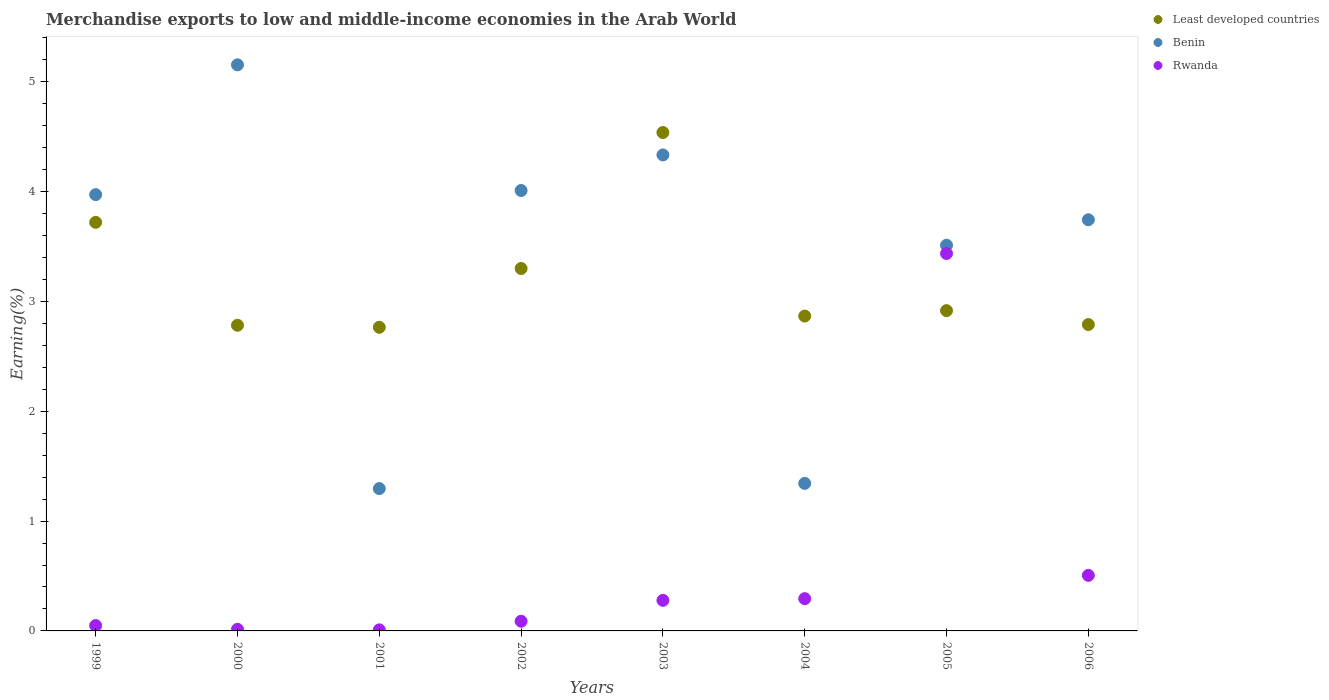What is the percentage of amount earned from merchandise exports in Benin in 1999?
Provide a short and direct response. 3.97. Across all years, what is the maximum percentage of amount earned from merchandise exports in Benin?
Provide a short and direct response. 5.15. Across all years, what is the minimum percentage of amount earned from merchandise exports in Least developed countries?
Keep it short and to the point. 2.76. What is the total percentage of amount earned from merchandise exports in Benin in the graph?
Make the answer very short. 27.37. What is the difference between the percentage of amount earned from merchandise exports in Rwanda in 2005 and that in 2006?
Keep it short and to the point. 2.93. What is the difference between the percentage of amount earned from merchandise exports in Rwanda in 2004 and the percentage of amount earned from merchandise exports in Benin in 2000?
Provide a short and direct response. -4.86. What is the average percentage of amount earned from merchandise exports in Least developed countries per year?
Your response must be concise. 3.21. In the year 2006, what is the difference between the percentage of amount earned from merchandise exports in Benin and percentage of amount earned from merchandise exports in Least developed countries?
Give a very brief answer. 0.95. What is the ratio of the percentage of amount earned from merchandise exports in Rwanda in 2000 to that in 2001?
Your response must be concise. 1.52. Is the percentage of amount earned from merchandise exports in Rwanda in 2004 less than that in 2005?
Make the answer very short. Yes. What is the difference between the highest and the second highest percentage of amount earned from merchandise exports in Benin?
Give a very brief answer. 0.82. What is the difference between the highest and the lowest percentage of amount earned from merchandise exports in Rwanda?
Keep it short and to the point. 3.43. Is the sum of the percentage of amount earned from merchandise exports in Benin in 1999 and 2005 greater than the maximum percentage of amount earned from merchandise exports in Least developed countries across all years?
Ensure brevity in your answer.  Yes. Is it the case that in every year, the sum of the percentage of amount earned from merchandise exports in Least developed countries and percentage of amount earned from merchandise exports in Rwanda  is greater than the percentage of amount earned from merchandise exports in Benin?
Provide a succinct answer. No. Does the percentage of amount earned from merchandise exports in Rwanda monotonically increase over the years?
Keep it short and to the point. No. Is the percentage of amount earned from merchandise exports in Rwanda strictly greater than the percentage of amount earned from merchandise exports in Least developed countries over the years?
Your answer should be compact. No. What is the title of the graph?
Ensure brevity in your answer.  Merchandise exports to low and middle-income economies in the Arab World. What is the label or title of the Y-axis?
Ensure brevity in your answer.  Earning(%). What is the Earning(%) of Least developed countries in 1999?
Offer a very short reply. 3.72. What is the Earning(%) of Benin in 1999?
Provide a short and direct response. 3.97. What is the Earning(%) of Rwanda in 1999?
Give a very brief answer. 0.05. What is the Earning(%) in Least developed countries in 2000?
Make the answer very short. 2.78. What is the Earning(%) in Benin in 2000?
Your answer should be compact. 5.15. What is the Earning(%) of Rwanda in 2000?
Provide a succinct answer. 0.01. What is the Earning(%) in Least developed countries in 2001?
Your response must be concise. 2.76. What is the Earning(%) of Benin in 2001?
Provide a succinct answer. 1.3. What is the Earning(%) of Rwanda in 2001?
Keep it short and to the point. 0.01. What is the Earning(%) in Least developed countries in 2002?
Your response must be concise. 3.3. What is the Earning(%) in Benin in 2002?
Offer a very short reply. 4.01. What is the Earning(%) in Rwanda in 2002?
Your answer should be very brief. 0.09. What is the Earning(%) in Least developed countries in 2003?
Provide a succinct answer. 4.54. What is the Earning(%) in Benin in 2003?
Provide a succinct answer. 4.33. What is the Earning(%) of Rwanda in 2003?
Offer a very short reply. 0.28. What is the Earning(%) of Least developed countries in 2004?
Your answer should be very brief. 2.87. What is the Earning(%) in Benin in 2004?
Give a very brief answer. 1.34. What is the Earning(%) in Rwanda in 2004?
Keep it short and to the point. 0.29. What is the Earning(%) of Least developed countries in 2005?
Your answer should be compact. 2.92. What is the Earning(%) in Benin in 2005?
Your answer should be compact. 3.51. What is the Earning(%) in Rwanda in 2005?
Your response must be concise. 3.44. What is the Earning(%) in Least developed countries in 2006?
Make the answer very short. 2.79. What is the Earning(%) of Benin in 2006?
Provide a succinct answer. 3.74. What is the Earning(%) of Rwanda in 2006?
Your answer should be compact. 0.51. Across all years, what is the maximum Earning(%) of Least developed countries?
Your response must be concise. 4.54. Across all years, what is the maximum Earning(%) in Benin?
Offer a very short reply. 5.15. Across all years, what is the maximum Earning(%) of Rwanda?
Offer a terse response. 3.44. Across all years, what is the minimum Earning(%) of Least developed countries?
Provide a short and direct response. 2.76. Across all years, what is the minimum Earning(%) in Benin?
Ensure brevity in your answer.  1.3. Across all years, what is the minimum Earning(%) of Rwanda?
Offer a terse response. 0.01. What is the total Earning(%) of Least developed countries in the graph?
Offer a terse response. 25.68. What is the total Earning(%) of Benin in the graph?
Provide a succinct answer. 27.37. What is the total Earning(%) of Rwanda in the graph?
Your answer should be very brief. 4.68. What is the difference between the Earning(%) of Least developed countries in 1999 and that in 2000?
Offer a terse response. 0.94. What is the difference between the Earning(%) in Benin in 1999 and that in 2000?
Your answer should be very brief. -1.18. What is the difference between the Earning(%) of Rwanda in 1999 and that in 2000?
Make the answer very short. 0.03. What is the difference between the Earning(%) of Least developed countries in 1999 and that in 2001?
Your answer should be compact. 0.96. What is the difference between the Earning(%) in Benin in 1999 and that in 2001?
Your response must be concise. 2.68. What is the difference between the Earning(%) in Rwanda in 1999 and that in 2001?
Your answer should be compact. 0.04. What is the difference between the Earning(%) of Least developed countries in 1999 and that in 2002?
Your answer should be compact. 0.42. What is the difference between the Earning(%) of Benin in 1999 and that in 2002?
Give a very brief answer. -0.04. What is the difference between the Earning(%) in Rwanda in 1999 and that in 2002?
Make the answer very short. -0.04. What is the difference between the Earning(%) of Least developed countries in 1999 and that in 2003?
Your answer should be compact. -0.82. What is the difference between the Earning(%) of Benin in 1999 and that in 2003?
Keep it short and to the point. -0.36. What is the difference between the Earning(%) of Rwanda in 1999 and that in 2003?
Give a very brief answer. -0.23. What is the difference between the Earning(%) in Least developed countries in 1999 and that in 2004?
Your answer should be very brief. 0.85. What is the difference between the Earning(%) in Benin in 1999 and that in 2004?
Provide a short and direct response. 2.63. What is the difference between the Earning(%) of Rwanda in 1999 and that in 2004?
Offer a very short reply. -0.24. What is the difference between the Earning(%) in Least developed countries in 1999 and that in 2005?
Provide a succinct answer. 0.8. What is the difference between the Earning(%) of Benin in 1999 and that in 2005?
Ensure brevity in your answer.  0.46. What is the difference between the Earning(%) of Rwanda in 1999 and that in 2005?
Ensure brevity in your answer.  -3.39. What is the difference between the Earning(%) of Least developed countries in 1999 and that in 2006?
Your answer should be very brief. 0.93. What is the difference between the Earning(%) of Benin in 1999 and that in 2006?
Your answer should be compact. 0.23. What is the difference between the Earning(%) in Rwanda in 1999 and that in 2006?
Make the answer very short. -0.46. What is the difference between the Earning(%) in Least developed countries in 2000 and that in 2001?
Your answer should be very brief. 0.02. What is the difference between the Earning(%) in Benin in 2000 and that in 2001?
Ensure brevity in your answer.  3.86. What is the difference between the Earning(%) of Rwanda in 2000 and that in 2001?
Offer a terse response. 0.01. What is the difference between the Earning(%) of Least developed countries in 2000 and that in 2002?
Your answer should be compact. -0.52. What is the difference between the Earning(%) of Benin in 2000 and that in 2002?
Make the answer very short. 1.14. What is the difference between the Earning(%) of Rwanda in 2000 and that in 2002?
Offer a very short reply. -0.07. What is the difference between the Earning(%) in Least developed countries in 2000 and that in 2003?
Keep it short and to the point. -1.75. What is the difference between the Earning(%) of Benin in 2000 and that in 2003?
Your answer should be very brief. 0.82. What is the difference between the Earning(%) in Rwanda in 2000 and that in 2003?
Provide a short and direct response. -0.26. What is the difference between the Earning(%) of Least developed countries in 2000 and that in 2004?
Offer a very short reply. -0.08. What is the difference between the Earning(%) in Benin in 2000 and that in 2004?
Ensure brevity in your answer.  3.81. What is the difference between the Earning(%) of Rwanda in 2000 and that in 2004?
Keep it short and to the point. -0.28. What is the difference between the Earning(%) of Least developed countries in 2000 and that in 2005?
Keep it short and to the point. -0.13. What is the difference between the Earning(%) of Benin in 2000 and that in 2005?
Keep it short and to the point. 1.64. What is the difference between the Earning(%) in Rwanda in 2000 and that in 2005?
Your answer should be compact. -3.42. What is the difference between the Earning(%) in Least developed countries in 2000 and that in 2006?
Offer a terse response. -0.01. What is the difference between the Earning(%) of Benin in 2000 and that in 2006?
Offer a terse response. 1.41. What is the difference between the Earning(%) of Rwanda in 2000 and that in 2006?
Ensure brevity in your answer.  -0.49. What is the difference between the Earning(%) of Least developed countries in 2001 and that in 2002?
Provide a short and direct response. -0.54. What is the difference between the Earning(%) of Benin in 2001 and that in 2002?
Provide a short and direct response. -2.71. What is the difference between the Earning(%) of Rwanda in 2001 and that in 2002?
Ensure brevity in your answer.  -0.08. What is the difference between the Earning(%) of Least developed countries in 2001 and that in 2003?
Ensure brevity in your answer.  -1.77. What is the difference between the Earning(%) of Benin in 2001 and that in 2003?
Your answer should be compact. -3.04. What is the difference between the Earning(%) of Rwanda in 2001 and that in 2003?
Your response must be concise. -0.27. What is the difference between the Earning(%) in Least developed countries in 2001 and that in 2004?
Give a very brief answer. -0.1. What is the difference between the Earning(%) of Benin in 2001 and that in 2004?
Keep it short and to the point. -0.05. What is the difference between the Earning(%) in Rwanda in 2001 and that in 2004?
Provide a succinct answer. -0.28. What is the difference between the Earning(%) in Least developed countries in 2001 and that in 2005?
Give a very brief answer. -0.15. What is the difference between the Earning(%) of Benin in 2001 and that in 2005?
Make the answer very short. -2.22. What is the difference between the Earning(%) of Rwanda in 2001 and that in 2005?
Provide a short and direct response. -3.43. What is the difference between the Earning(%) of Least developed countries in 2001 and that in 2006?
Offer a terse response. -0.02. What is the difference between the Earning(%) in Benin in 2001 and that in 2006?
Offer a very short reply. -2.45. What is the difference between the Earning(%) of Rwanda in 2001 and that in 2006?
Give a very brief answer. -0.5. What is the difference between the Earning(%) in Least developed countries in 2002 and that in 2003?
Provide a succinct answer. -1.24. What is the difference between the Earning(%) in Benin in 2002 and that in 2003?
Your response must be concise. -0.32. What is the difference between the Earning(%) in Rwanda in 2002 and that in 2003?
Provide a short and direct response. -0.19. What is the difference between the Earning(%) in Least developed countries in 2002 and that in 2004?
Provide a short and direct response. 0.43. What is the difference between the Earning(%) in Benin in 2002 and that in 2004?
Make the answer very short. 2.67. What is the difference between the Earning(%) in Rwanda in 2002 and that in 2004?
Offer a terse response. -0.21. What is the difference between the Earning(%) of Least developed countries in 2002 and that in 2005?
Provide a short and direct response. 0.38. What is the difference between the Earning(%) in Benin in 2002 and that in 2005?
Keep it short and to the point. 0.5. What is the difference between the Earning(%) in Rwanda in 2002 and that in 2005?
Make the answer very short. -3.35. What is the difference between the Earning(%) of Least developed countries in 2002 and that in 2006?
Ensure brevity in your answer.  0.51. What is the difference between the Earning(%) in Benin in 2002 and that in 2006?
Make the answer very short. 0.27. What is the difference between the Earning(%) in Rwanda in 2002 and that in 2006?
Your answer should be very brief. -0.42. What is the difference between the Earning(%) of Least developed countries in 2003 and that in 2004?
Provide a short and direct response. 1.67. What is the difference between the Earning(%) in Benin in 2003 and that in 2004?
Provide a short and direct response. 2.99. What is the difference between the Earning(%) of Rwanda in 2003 and that in 2004?
Provide a short and direct response. -0.02. What is the difference between the Earning(%) of Least developed countries in 2003 and that in 2005?
Make the answer very short. 1.62. What is the difference between the Earning(%) of Benin in 2003 and that in 2005?
Give a very brief answer. 0.82. What is the difference between the Earning(%) of Rwanda in 2003 and that in 2005?
Provide a succinct answer. -3.16. What is the difference between the Earning(%) of Least developed countries in 2003 and that in 2006?
Make the answer very short. 1.75. What is the difference between the Earning(%) of Benin in 2003 and that in 2006?
Your answer should be compact. 0.59. What is the difference between the Earning(%) of Rwanda in 2003 and that in 2006?
Make the answer very short. -0.23. What is the difference between the Earning(%) of Least developed countries in 2004 and that in 2005?
Offer a very short reply. -0.05. What is the difference between the Earning(%) of Benin in 2004 and that in 2005?
Give a very brief answer. -2.17. What is the difference between the Earning(%) of Rwanda in 2004 and that in 2005?
Offer a terse response. -3.14. What is the difference between the Earning(%) in Least developed countries in 2004 and that in 2006?
Make the answer very short. 0.08. What is the difference between the Earning(%) in Benin in 2004 and that in 2006?
Offer a terse response. -2.4. What is the difference between the Earning(%) of Rwanda in 2004 and that in 2006?
Your answer should be compact. -0.21. What is the difference between the Earning(%) of Least developed countries in 2005 and that in 2006?
Your response must be concise. 0.13. What is the difference between the Earning(%) in Benin in 2005 and that in 2006?
Make the answer very short. -0.23. What is the difference between the Earning(%) in Rwanda in 2005 and that in 2006?
Give a very brief answer. 2.93. What is the difference between the Earning(%) in Least developed countries in 1999 and the Earning(%) in Benin in 2000?
Give a very brief answer. -1.43. What is the difference between the Earning(%) of Least developed countries in 1999 and the Earning(%) of Rwanda in 2000?
Ensure brevity in your answer.  3.71. What is the difference between the Earning(%) of Benin in 1999 and the Earning(%) of Rwanda in 2000?
Make the answer very short. 3.96. What is the difference between the Earning(%) of Least developed countries in 1999 and the Earning(%) of Benin in 2001?
Ensure brevity in your answer.  2.42. What is the difference between the Earning(%) of Least developed countries in 1999 and the Earning(%) of Rwanda in 2001?
Give a very brief answer. 3.71. What is the difference between the Earning(%) of Benin in 1999 and the Earning(%) of Rwanda in 2001?
Your answer should be compact. 3.96. What is the difference between the Earning(%) in Least developed countries in 1999 and the Earning(%) in Benin in 2002?
Provide a succinct answer. -0.29. What is the difference between the Earning(%) of Least developed countries in 1999 and the Earning(%) of Rwanda in 2002?
Keep it short and to the point. 3.63. What is the difference between the Earning(%) of Benin in 1999 and the Earning(%) of Rwanda in 2002?
Your answer should be very brief. 3.88. What is the difference between the Earning(%) of Least developed countries in 1999 and the Earning(%) of Benin in 2003?
Your response must be concise. -0.61. What is the difference between the Earning(%) in Least developed countries in 1999 and the Earning(%) in Rwanda in 2003?
Your answer should be very brief. 3.44. What is the difference between the Earning(%) of Benin in 1999 and the Earning(%) of Rwanda in 2003?
Offer a terse response. 3.69. What is the difference between the Earning(%) in Least developed countries in 1999 and the Earning(%) in Benin in 2004?
Offer a very short reply. 2.38. What is the difference between the Earning(%) of Least developed countries in 1999 and the Earning(%) of Rwanda in 2004?
Your answer should be compact. 3.43. What is the difference between the Earning(%) in Benin in 1999 and the Earning(%) in Rwanda in 2004?
Provide a short and direct response. 3.68. What is the difference between the Earning(%) of Least developed countries in 1999 and the Earning(%) of Benin in 2005?
Ensure brevity in your answer.  0.21. What is the difference between the Earning(%) in Least developed countries in 1999 and the Earning(%) in Rwanda in 2005?
Make the answer very short. 0.28. What is the difference between the Earning(%) of Benin in 1999 and the Earning(%) of Rwanda in 2005?
Provide a short and direct response. 0.54. What is the difference between the Earning(%) of Least developed countries in 1999 and the Earning(%) of Benin in 2006?
Give a very brief answer. -0.02. What is the difference between the Earning(%) of Least developed countries in 1999 and the Earning(%) of Rwanda in 2006?
Offer a very short reply. 3.21. What is the difference between the Earning(%) in Benin in 1999 and the Earning(%) in Rwanda in 2006?
Your answer should be compact. 3.47. What is the difference between the Earning(%) of Least developed countries in 2000 and the Earning(%) of Benin in 2001?
Your answer should be compact. 1.49. What is the difference between the Earning(%) of Least developed countries in 2000 and the Earning(%) of Rwanda in 2001?
Ensure brevity in your answer.  2.77. What is the difference between the Earning(%) of Benin in 2000 and the Earning(%) of Rwanda in 2001?
Your answer should be very brief. 5.14. What is the difference between the Earning(%) of Least developed countries in 2000 and the Earning(%) of Benin in 2002?
Offer a very short reply. -1.23. What is the difference between the Earning(%) in Least developed countries in 2000 and the Earning(%) in Rwanda in 2002?
Make the answer very short. 2.69. What is the difference between the Earning(%) of Benin in 2000 and the Earning(%) of Rwanda in 2002?
Your answer should be very brief. 5.07. What is the difference between the Earning(%) in Least developed countries in 2000 and the Earning(%) in Benin in 2003?
Your answer should be compact. -1.55. What is the difference between the Earning(%) in Least developed countries in 2000 and the Earning(%) in Rwanda in 2003?
Your answer should be very brief. 2.5. What is the difference between the Earning(%) of Benin in 2000 and the Earning(%) of Rwanda in 2003?
Ensure brevity in your answer.  4.88. What is the difference between the Earning(%) of Least developed countries in 2000 and the Earning(%) of Benin in 2004?
Offer a very short reply. 1.44. What is the difference between the Earning(%) of Least developed countries in 2000 and the Earning(%) of Rwanda in 2004?
Offer a very short reply. 2.49. What is the difference between the Earning(%) of Benin in 2000 and the Earning(%) of Rwanda in 2004?
Keep it short and to the point. 4.86. What is the difference between the Earning(%) of Least developed countries in 2000 and the Earning(%) of Benin in 2005?
Provide a short and direct response. -0.73. What is the difference between the Earning(%) in Least developed countries in 2000 and the Earning(%) in Rwanda in 2005?
Provide a succinct answer. -0.65. What is the difference between the Earning(%) in Benin in 2000 and the Earning(%) in Rwanda in 2005?
Make the answer very short. 1.72. What is the difference between the Earning(%) of Least developed countries in 2000 and the Earning(%) of Benin in 2006?
Your answer should be very brief. -0.96. What is the difference between the Earning(%) of Least developed countries in 2000 and the Earning(%) of Rwanda in 2006?
Keep it short and to the point. 2.28. What is the difference between the Earning(%) of Benin in 2000 and the Earning(%) of Rwanda in 2006?
Your answer should be very brief. 4.65. What is the difference between the Earning(%) of Least developed countries in 2001 and the Earning(%) of Benin in 2002?
Keep it short and to the point. -1.25. What is the difference between the Earning(%) of Least developed countries in 2001 and the Earning(%) of Rwanda in 2002?
Offer a very short reply. 2.68. What is the difference between the Earning(%) of Benin in 2001 and the Earning(%) of Rwanda in 2002?
Provide a succinct answer. 1.21. What is the difference between the Earning(%) in Least developed countries in 2001 and the Earning(%) in Benin in 2003?
Ensure brevity in your answer.  -1.57. What is the difference between the Earning(%) in Least developed countries in 2001 and the Earning(%) in Rwanda in 2003?
Your answer should be compact. 2.49. What is the difference between the Earning(%) of Benin in 2001 and the Earning(%) of Rwanda in 2003?
Make the answer very short. 1.02. What is the difference between the Earning(%) in Least developed countries in 2001 and the Earning(%) in Benin in 2004?
Keep it short and to the point. 1.42. What is the difference between the Earning(%) of Least developed countries in 2001 and the Earning(%) of Rwanda in 2004?
Keep it short and to the point. 2.47. What is the difference between the Earning(%) of Benin in 2001 and the Earning(%) of Rwanda in 2004?
Your response must be concise. 1. What is the difference between the Earning(%) of Least developed countries in 2001 and the Earning(%) of Benin in 2005?
Offer a terse response. -0.75. What is the difference between the Earning(%) in Least developed countries in 2001 and the Earning(%) in Rwanda in 2005?
Keep it short and to the point. -0.67. What is the difference between the Earning(%) in Benin in 2001 and the Earning(%) in Rwanda in 2005?
Ensure brevity in your answer.  -2.14. What is the difference between the Earning(%) in Least developed countries in 2001 and the Earning(%) in Benin in 2006?
Ensure brevity in your answer.  -0.98. What is the difference between the Earning(%) in Least developed countries in 2001 and the Earning(%) in Rwanda in 2006?
Make the answer very short. 2.26. What is the difference between the Earning(%) of Benin in 2001 and the Earning(%) of Rwanda in 2006?
Keep it short and to the point. 0.79. What is the difference between the Earning(%) of Least developed countries in 2002 and the Earning(%) of Benin in 2003?
Your answer should be very brief. -1.03. What is the difference between the Earning(%) of Least developed countries in 2002 and the Earning(%) of Rwanda in 2003?
Give a very brief answer. 3.02. What is the difference between the Earning(%) of Benin in 2002 and the Earning(%) of Rwanda in 2003?
Make the answer very short. 3.73. What is the difference between the Earning(%) in Least developed countries in 2002 and the Earning(%) in Benin in 2004?
Provide a short and direct response. 1.96. What is the difference between the Earning(%) in Least developed countries in 2002 and the Earning(%) in Rwanda in 2004?
Keep it short and to the point. 3.01. What is the difference between the Earning(%) of Benin in 2002 and the Earning(%) of Rwanda in 2004?
Give a very brief answer. 3.72. What is the difference between the Earning(%) in Least developed countries in 2002 and the Earning(%) in Benin in 2005?
Ensure brevity in your answer.  -0.21. What is the difference between the Earning(%) of Least developed countries in 2002 and the Earning(%) of Rwanda in 2005?
Ensure brevity in your answer.  -0.14. What is the difference between the Earning(%) of Benin in 2002 and the Earning(%) of Rwanda in 2005?
Ensure brevity in your answer.  0.57. What is the difference between the Earning(%) of Least developed countries in 2002 and the Earning(%) of Benin in 2006?
Provide a short and direct response. -0.44. What is the difference between the Earning(%) of Least developed countries in 2002 and the Earning(%) of Rwanda in 2006?
Keep it short and to the point. 2.79. What is the difference between the Earning(%) of Benin in 2002 and the Earning(%) of Rwanda in 2006?
Your answer should be compact. 3.5. What is the difference between the Earning(%) in Least developed countries in 2003 and the Earning(%) in Benin in 2004?
Provide a succinct answer. 3.19. What is the difference between the Earning(%) of Least developed countries in 2003 and the Earning(%) of Rwanda in 2004?
Your response must be concise. 4.24. What is the difference between the Earning(%) of Benin in 2003 and the Earning(%) of Rwanda in 2004?
Make the answer very short. 4.04. What is the difference between the Earning(%) of Least developed countries in 2003 and the Earning(%) of Benin in 2005?
Keep it short and to the point. 1.03. What is the difference between the Earning(%) of Least developed countries in 2003 and the Earning(%) of Rwanda in 2005?
Keep it short and to the point. 1.1. What is the difference between the Earning(%) in Benin in 2003 and the Earning(%) in Rwanda in 2005?
Provide a short and direct response. 0.9. What is the difference between the Earning(%) in Least developed countries in 2003 and the Earning(%) in Benin in 2006?
Ensure brevity in your answer.  0.79. What is the difference between the Earning(%) in Least developed countries in 2003 and the Earning(%) in Rwanda in 2006?
Provide a short and direct response. 4.03. What is the difference between the Earning(%) of Benin in 2003 and the Earning(%) of Rwanda in 2006?
Give a very brief answer. 3.83. What is the difference between the Earning(%) of Least developed countries in 2004 and the Earning(%) of Benin in 2005?
Your answer should be very brief. -0.64. What is the difference between the Earning(%) of Least developed countries in 2004 and the Earning(%) of Rwanda in 2005?
Make the answer very short. -0.57. What is the difference between the Earning(%) in Benin in 2004 and the Earning(%) in Rwanda in 2005?
Ensure brevity in your answer.  -2.09. What is the difference between the Earning(%) of Least developed countries in 2004 and the Earning(%) of Benin in 2006?
Keep it short and to the point. -0.88. What is the difference between the Earning(%) in Least developed countries in 2004 and the Earning(%) in Rwanda in 2006?
Give a very brief answer. 2.36. What is the difference between the Earning(%) of Benin in 2004 and the Earning(%) of Rwanda in 2006?
Offer a very short reply. 0.84. What is the difference between the Earning(%) of Least developed countries in 2005 and the Earning(%) of Benin in 2006?
Your answer should be very brief. -0.83. What is the difference between the Earning(%) of Least developed countries in 2005 and the Earning(%) of Rwanda in 2006?
Your response must be concise. 2.41. What is the difference between the Earning(%) in Benin in 2005 and the Earning(%) in Rwanda in 2006?
Your answer should be compact. 3.01. What is the average Earning(%) of Least developed countries per year?
Ensure brevity in your answer.  3.21. What is the average Earning(%) of Benin per year?
Give a very brief answer. 3.42. What is the average Earning(%) of Rwanda per year?
Your response must be concise. 0.58. In the year 1999, what is the difference between the Earning(%) of Least developed countries and Earning(%) of Benin?
Provide a short and direct response. -0.25. In the year 1999, what is the difference between the Earning(%) of Least developed countries and Earning(%) of Rwanda?
Provide a short and direct response. 3.67. In the year 1999, what is the difference between the Earning(%) of Benin and Earning(%) of Rwanda?
Your answer should be compact. 3.92. In the year 2000, what is the difference between the Earning(%) of Least developed countries and Earning(%) of Benin?
Offer a very short reply. -2.37. In the year 2000, what is the difference between the Earning(%) in Least developed countries and Earning(%) in Rwanda?
Offer a terse response. 2.77. In the year 2000, what is the difference between the Earning(%) in Benin and Earning(%) in Rwanda?
Offer a terse response. 5.14. In the year 2001, what is the difference between the Earning(%) in Least developed countries and Earning(%) in Benin?
Your answer should be very brief. 1.47. In the year 2001, what is the difference between the Earning(%) in Least developed countries and Earning(%) in Rwanda?
Keep it short and to the point. 2.75. In the year 2001, what is the difference between the Earning(%) of Benin and Earning(%) of Rwanda?
Keep it short and to the point. 1.29. In the year 2002, what is the difference between the Earning(%) of Least developed countries and Earning(%) of Benin?
Give a very brief answer. -0.71. In the year 2002, what is the difference between the Earning(%) of Least developed countries and Earning(%) of Rwanda?
Make the answer very short. 3.21. In the year 2002, what is the difference between the Earning(%) of Benin and Earning(%) of Rwanda?
Offer a terse response. 3.92. In the year 2003, what is the difference between the Earning(%) in Least developed countries and Earning(%) in Benin?
Provide a short and direct response. 0.2. In the year 2003, what is the difference between the Earning(%) in Least developed countries and Earning(%) in Rwanda?
Your answer should be very brief. 4.26. In the year 2003, what is the difference between the Earning(%) in Benin and Earning(%) in Rwanda?
Offer a very short reply. 4.06. In the year 2004, what is the difference between the Earning(%) of Least developed countries and Earning(%) of Benin?
Provide a succinct answer. 1.52. In the year 2004, what is the difference between the Earning(%) of Least developed countries and Earning(%) of Rwanda?
Give a very brief answer. 2.57. In the year 2004, what is the difference between the Earning(%) of Benin and Earning(%) of Rwanda?
Make the answer very short. 1.05. In the year 2005, what is the difference between the Earning(%) in Least developed countries and Earning(%) in Benin?
Your answer should be compact. -0.6. In the year 2005, what is the difference between the Earning(%) in Least developed countries and Earning(%) in Rwanda?
Offer a terse response. -0.52. In the year 2005, what is the difference between the Earning(%) in Benin and Earning(%) in Rwanda?
Make the answer very short. 0.08. In the year 2006, what is the difference between the Earning(%) of Least developed countries and Earning(%) of Benin?
Offer a very short reply. -0.95. In the year 2006, what is the difference between the Earning(%) in Least developed countries and Earning(%) in Rwanda?
Ensure brevity in your answer.  2.28. In the year 2006, what is the difference between the Earning(%) of Benin and Earning(%) of Rwanda?
Your answer should be compact. 3.24. What is the ratio of the Earning(%) in Least developed countries in 1999 to that in 2000?
Offer a very short reply. 1.34. What is the ratio of the Earning(%) of Benin in 1999 to that in 2000?
Offer a very short reply. 0.77. What is the ratio of the Earning(%) in Rwanda in 1999 to that in 2000?
Your answer should be compact. 3.3. What is the ratio of the Earning(%) of Least developed countries in 1999 to that in 2001?
Give a very brief answer. 1.35. What is the ratio of the Earning(%) of Benin in 1999 to that in 2001?
Make the answer very short. 3.07. What is the ratio of the Earning(%) of Rwanda in 1999 to that in 2001?
Ensure brevity in your answer.  5.01. What is the ratio of the Earning(%) in Least developed countries in 1999 to that in 2002?
Offer a very short reply. 1.13. What is the ratio of the Earning(%) in Benin in 1999 to that in 2002?
Provide a short and direct response. 0.99. What is the ratio of the Earning(%) in Rwanda in 1999 to that in 2002?
Keep it short and to the point. 0.55. What is the ratio of the Earning(%) of Least developed countries in 1999 to that in 2003?
Your response must be concise. 0.82. What is the ratio of the Earning(%) in Benin in 1999 to that in 2003?
Make the answer very short. 0.92. What is the ratio of the Earning(%) of Rwanda in 1999 to that in 2003?
Your answer should be very brief. 0.18. What is the ratio of the Earning(%) in Least developed countries in 1999 to that in 2004?
Provide a short and direct response. 1.3. What is the ratio of the Earning(%) of Benin in 1999 to that in 2004?
Your answer should be very brief. 2.96. What is the ratio of the Earning(%) of Rwanda in 1999 to that in 2004?
Your answer should be compact. 0.17. What is the ratio of the Earning(%) in Least developed countries in 1999 to that in 2005?
Give a very brief answer. 1.28. What is the ratio of the Earning(%) in Benin in 1999 to that in 2005?
Your response must be concise. 1.13. What is the ratio of the Earning(%) in Rwanda in 1999 to that in 2005?
Keep it short and to the point. 0.01. What is the ratio of the Earning(%) in Least developed countries in 1999 to that in 2006?
Provide a succinct answer. 1.33. What is the ratio of the Earning(%) in Benin in 1999 to that in 2006?
Provide a succinct answer. 1.06. What is the ratio of the Earning(%) in Rwanda in 1999 to that in 2006?
Your answer should be compact. 0.1. What is the ratio of the Earning(%) in Least developed countries in 2000 to that in 2001?
Offer a terse response. 1.01. What is the ratio of the Earning(%) of Benin in 2000 to that in 2001?
Your answer should be compact. 3.98. What is the ratio of the Earning(%) in Rwanda in 2000 to that in 2001?
Make the answer very short. 1.52. What is the ratio of the Earning(%) in Least developed countries in 2000 to that in 2002?
Offer a terse response. 0.84. What is the ratio of the Earning(%) in Benin in 2000 to that in 2002?
Ensure brevity in your answer.  1.29. What is the ratio of the Earning(%) in Rwanda in 2000 to that in 2002?
Ensure brevity in your answer.  0.17. What is the ratio of the Earning(%) in Least developed countries in 2000 to that in 2003?
Your answer should be compact. 0.61. What is the ratio of the Earning(%) of Benin in 2000 to that in 2003?
Provide a succinct answer. 1.19. What is the ratio of the Earning(%) of Rwanda in 2000 to that in 2003?
Keep it short and to the point. 0.05. What is the ratio of the Earning(%) in Least developed countries in 2000 to that in 2004?
Provide a succinct answer. 0.97. What is the ratio of the Earning(%) of Benin in 2000 to that in 2004?
Your answer should be very brief. 3.84. What is the ratio of the Earning(%) of Rwanda in 2000 to that in 2004?
Ensure brevity in your answer.  0.05. What is the ratio of the Earning(%) in Least developed countries in 2000 to that in 2005?
Ensure brevity in your answer.  0.95. What is the ratio of the Earning(%) in Benin in 2000 to that in 2005?
Your answer should be compact. 1.47. What is the ratio of the Earning(%) in Rwanda in 2000 to that in 2005?
Ensure brevity in your answer.  0. What is the ratio of the Earning(%) of Least developed countries in 2000 to that in 2006?
Your response must be concise. 1. What is the ratio of the Earning(%) of Benin in 2000 to that in 2006?
Offer a terse response. 1.38. What is the ratio of the Earning(%) of Rwanda in 2000 to that in 2006?
Provide a succinct answer. 0.03. What is the ratio of the Earning(%) of Least developed countries in 2001 to that in 2002?
Offer a very short reply. 0.84. What is the ratio of the Earning(%) of Benin in 2001 to that in 2002?
Provide a succinct answer. 0.32. What is the ratio of the Earning(%) of Rwanda in 2001 to that in 2002?
Provide a short and direct response. 0.11. What is the ratio of the Earning(%) in Least developed countries in 2001 to that in 2003?
Offer a very short reply. 0.61. What is the ratio of the Earning(%) in Benin in 2001 to that in 2003?
Your response must be concise. 0.3. What is the ratio of the Earning(%) of Rwanda in 2001 to that in 2003?
Your answer should be compact. 0.04. What is the ratio of the Earning(%) in Least developed countries in 2001 to that in 2004?
Provide a short and direct response. 0.96. What is the ratio of the Earning(%) of Benin in 2001 to that in 2004?
Offer a terse response. 0.96. What is the ratio of the Earning(%) of Rwanda in 2001 to that in 2004?
Keep it short and to the point. 0.03. What is the ratio of the Earning(%) in Least developed countries in 2001 to that in 2005?
Offer a very short reply. 0.95. What is the ratio of the Earning(%) of Benin in 2001 to that in 2005?
Your response must be concise. 0.37. What is the ratio of the Earning(%) in Rwanda in 2001 to that in 2005?
Make the answer very short. 0. What is the ratio of the Earning(%) in Benin in 2001 to that in 2006?
Your answer should be compact. 0.35. What is the ratio of the Earning(%) in Rwanda in 2001 to that in 2006?
Give a very brief answer. 0.02. What is the ratio of the Earning(%) of Least developed countries in 2002 to that in 2003?
Keep it short and to the point. 0.73. What is the ratio of the Earning(%) of Benin in 2002 to that in 2003?
Give a very brief answer. 0.93. What is the ratio of the Earning(%) of Rwanda in 2002 to that in 2003?
Keep it short and to the point. 0.32. What is the ratio of the Earning(%) of Least developed countries in 2002 to that in 2004?
Give a very brief answer. 1.15. What is the ratio of the Earning(%) in Benin in 2002 to that in 2004?
Ensure brevity in your answer.  2.99. What is the ratio of the Earning(%) in Rwanda in 2002 to that in 2004?
Give a very brief answer. 0.3. What is the ratio of the Earning(%) of Least developed countries in 2002 to that in 2005?
Your response must be concise. 1.13. What is the ratio of the Earning(%) of Benin in 2002 to that in 2005?
Offer a very short reply. 1.14. What is the ratio of the Earning(%) of Rwanda in 2002 to that in 2005?
Provide a short and direct response. 0.03. What is the ratio of the Earning(%) in Least developed countries in 2002 to that in 2006?
Provide a succinct answer. 1.18. What is the ratio of the Earning(%) of Benin in 2002 to that in 2006?
Keep it short and to the point. 1.07. What is the ratio of the Earning(%) of Rwanda in 2002 to that in 2006?
Keep it short and to the point. 0.17. What is the ratio of the Earning(%) of Least developed countries in 2003 to that in 2004?
Give a very brief answer. 1.58. What is the ratio of the Earning(%) of Benin in 2003 to that in 2004?
Your answer should be compact. 3.23. What is the ratio of the Earning(%) of Rwanda in 2003 to that in 2004?
Your answer should be very brief. 0.95. What is the ratio of the Earning(%) of Least developed countries in 2003 to that in 2005?
Your response must be concise. 1.56. What is the ratio of the Earning(%) in Benin in 2003 to that in 2005?
Offer a terse response. 1.23. What is the ratio of the Earning(%) in Rwanda in 2003 to that in 2005?
Offer a very short reply. 0.08. What is the ratio of the Earning(%) in Least developed countries in 2003 to that in 2006?
Offer a very short reply. 1.63. What is the ratio of the Earning(%) in Benin in 2003 to that in 2006?
Ensure brevity in your answer.  1.16. What is the ratio of the Earning(%) in Rwanda in 2003 to that in 2006?
Make the answer very short. 0.55. What is the ratio of the Earning(%) of Least developed countries in 2004 to that in 2005?
Offer a terse response. 0.98. What is the ratio of the Earning(%) of Benin in 2004 to that in 2005?
Provide a short and direct response. 0.38. What is the ratio of the Earning(%) of Rwanda in 2004 to that in 2005?
Make the answer very short. 0.09. What is the ratio of the Earning(%) of Least developed countries in 2004 to that in 2006?
Ensure brevity in your answer.  1.03. What is the ratio of the Earning(%) of Benin in 2004 to that in 2006?
Offer a terse response. 0.36. What is the ratio of the Earning(%) of Rwanda in 2004 to that in 2006?
Your response must be concise. 0.58. What is the ratio of the Earning(%) of Least developed countries in 2005 to that in 2006?
Provide a succinct answer. 1.05. What is the ratio of the Earning(%) in Benin in 2005 to that in 2006?
Provide a succinct answer. 0.94. What is the ratio of the Earning(%) of Rwanda in 2005 to that in 2006?
Offer a terse response. 6.79. What is the difference between the highest and the second highest Earning(%) of Least developed countries?
Your response must be concise. 0.82. What is the difference between the highest and the second highest Earning(%) of Benin?
Give a very brief answer. 0.82. What is the difference between the highest and the second highest Earning(%) of Rwanda?
Give a very brief answer. 2.93. What is the difference between the highest and the lowest Earning(%) in Least developed countries?
Provide a short and direct response. 1.77. What is the difference between the highest and the lowest Earning(%) in Benin?
Your answer should be very brief. 3.86. What is the difference between the highest and the lowest Earning(%) of Rwanda?
Offer a terse response. 3.43. 